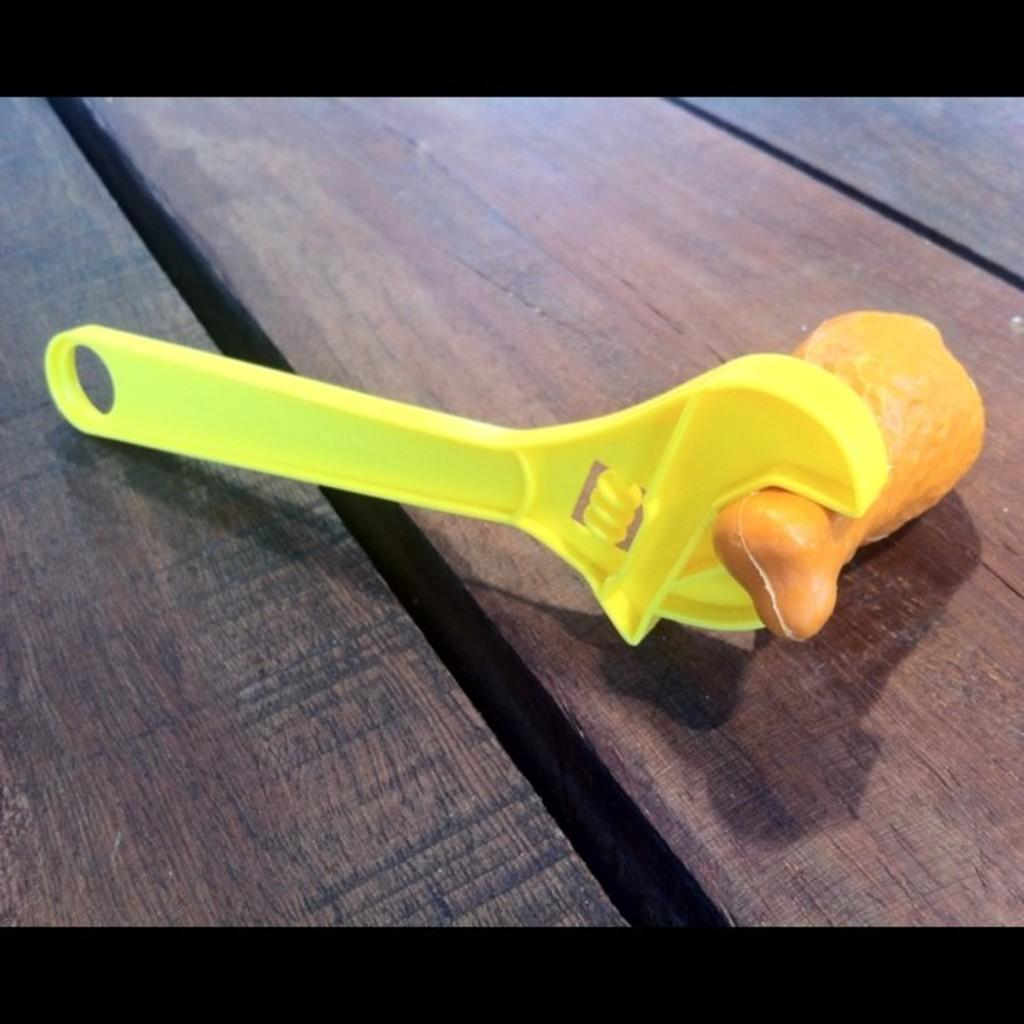What type of tool is visible in the image? There is a plastic wrench in the image. What other plastic object can be seen in the image? There is a plastic bone in the image. Where are the plastic objects placed in the image? Both objects are on a wooden plank. What type of smoke can be seen coming from the plastic wrench in the image? There is no smoke present in the image, as it features a plastic wrench and a plastic bone on a wooden plank. What language is being spoken by the plastic objects in the image? The plastic objects are inanimate and therefore cannot speak any language. 